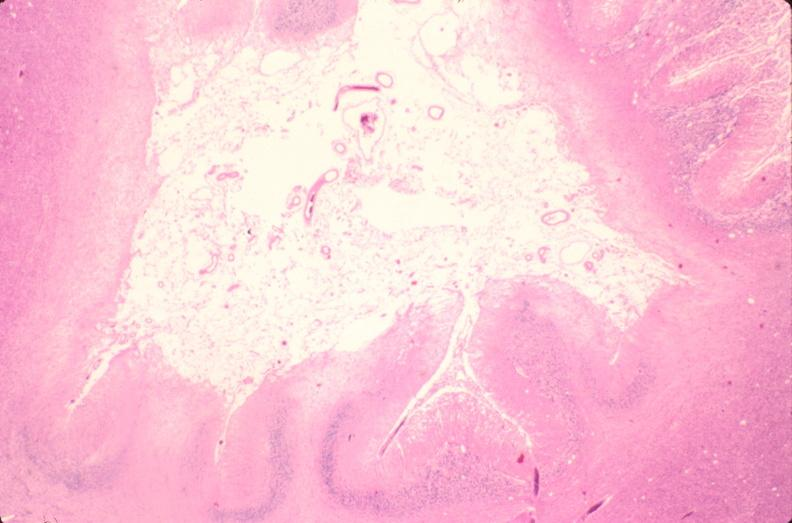does this image show brain, old infarcts, embolic?
Answer the question using a single word or phrase. Yes 